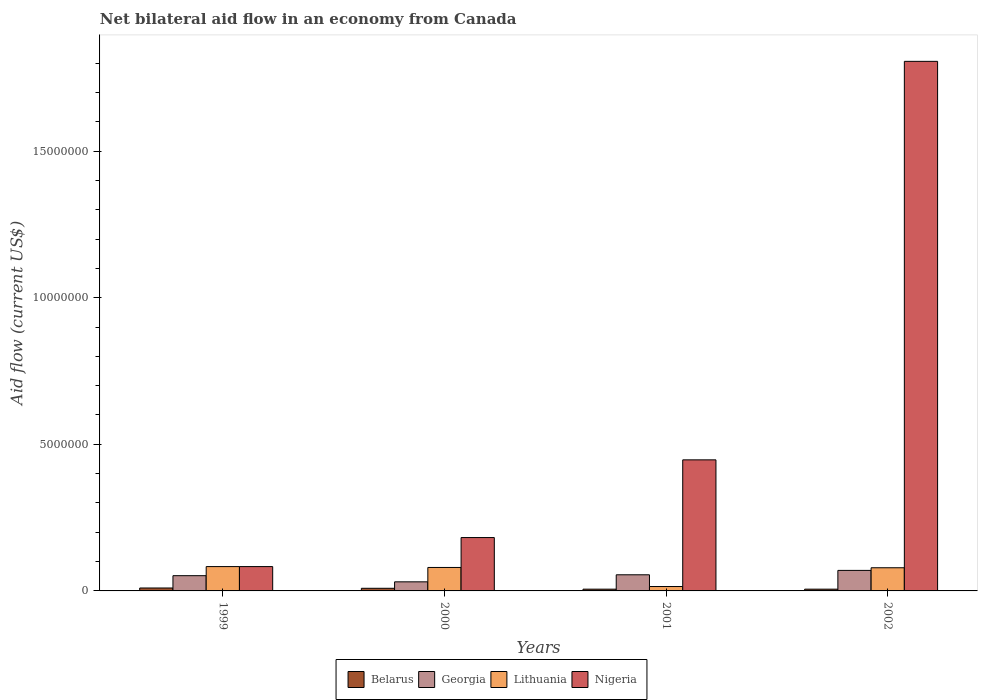Are the number of bars per tick equal to the number of legend labels?
Give a very brief answer. Yes. What is the label of the 3rd group of bars from the left?
Ensure brevity in your answer.  2001. In how many cases, is the number of bars for a given year not equal to the number of legend labels?
Keep it short and to the point. 0. What is the net bilateral aid flow in Georgia in 1999?
Offer a very short reply. 5.20e+05. Across all years, what is the maximum net bilateral aid flow in Lithuania?
Your response must be concise. 8.30e+05. In which year was the net bilateral aid flow in Lithuania maximum?
Offer a terse response. 1999. In which year was the net bilateral aid flow in Belarus minimum?
Your answer should be compact. 2001. What is the total net bilateral aid flow in Nigeria in the graph?
Ensure brevity in your answer.  2.52e+07. What is the difference between the net bilateral aid flow in Lithuania in 2001 and that in 2002?
Your answer should be very brief. -6.40e+05. What is the difference between the net bilateral aid flow in Belarus in 2001 and the net bilateral aid flow in Georgia in 1999?
Your answer should be very brief. -4.60e+05. What is the average net bilateral aid flow in Belarus per year?
Offer a terse response. 7.75e+04. In the year 2000, what is the difference between the net bilateral aid flow in Belarus and net bilateral aid flow in Lithuania?
Ensure brevity in your answer.  -7.10e+05. What is the ratio of the net bilateral aid flow in Belarus in 1999 to that in 2001?
Offer a very short reply. 1.67. What is the difference between the highest and the second highest net bilateral aid flow in Belarus?
Keep it short and to the point. 10000. What is the difference between the highest and the lowest net bilateral aid flow in Lithuania?
Ensure brevity in your answer.  6.80e+05. In how many years, is the net bilateral aid flow in Nigeria greater than the average net bilateral aid flow in Nigeria taken over all years?
Your answer should be very brief. 1. Is it the case that in every year, the sum of the net bilateral aid flow in Lithuania and net bilateral aid flow in Belarus is greater than the sum of net bilateral aid flow in Georgia and net bilateral aid flow in Nigeria?
Make the answer very short. No. What does the 3rd bar from the left in 2001 represents?
Offer a very short reply. Lithuania. What does the 4th bar from the right in 2000 represents?
Provide a short and direct response. Belarus. Is it the case that in every year, the sum of the net bilateral aid flow in Belarus and net bilateral aid flow in Georgia is greater than the net bilateral aid flow in Nigeria?
Your answer should be very brief. No. How many bars are there?
Give a very brief answer. 16. Are all the bars in the graph horizontal?
Ensure brevity in your answer.  No. Are the values on the major ticks of Y-axis written in scientific E-notation?
Provide a succinct answer. No. Does the graph contain grids?
Make the answer very short. No. Where does the legend appear in the graph?
Your response must be concise. Bottom center. How many legend labels are there?
Make the answer very short. 4. What is the title of the graph?
Keep it short and to the point. Net bilateral aid flow in an economy from Canada. What is the label or title of the X-axis?
Offer a very short reply. Years. What is the label or title of the Y-axis?
Your answer should be compact. Aid flow (current US$). What is the Aid flow (current US$) of Belarus in 1999?
Your answer should be compact. 1.00e+05. What is the Aid flow (current US$) in Georgia in 1999?
Your answer should be very brief. 5.20e+05. What is the Aid flow (current US$) of Lithuania in 1999?
Your response must be concise. 8.30e+05. What is the Aid flow (current US$) of Nigeria in 1999?
Provide a succinct answer. 8.30e+05. What is the Aid flow (current US$) in Belarus in 2000?
Keep it short and to the point. 9.00e+04. What is the Aid flow (current US$) in Lithuania in 2000?
Your response must be concise. 8.00e+05. What is the Aid flow (current US$) of Nigeria in 2000?
Provide a short and direct response. 1.82e+06. What is the Aid flow (current US$) of Georgia in 2001?
Ensure brevity in your answer.  5.50e+05. What is the Aid flow (current US$) of Lithuania in 2001?
Provide a succinct answer. 1.50e+05. What is the Aid flow (current US$) in Nigeria in 2001?
Your answer should be very brief. 4.47e+06. What is the Aid flow (current US$) of Lithuania in 2002?
Your response must be concise. 7.90e+05. What is the Aid flow (current US$) in Nigeria in 2002?
Keep it short and to the point. 1.81e+07. Across all years, what is the maximum Aid flow (current US$) in Georgia?
Offer a terse response. 7.00e+05. Across all years, what is the maximum Aid flow (current US$) in Lithuania?
Provide a succinct answer. 8.30e+05. Across all years, what is the maximum Aid flow (current US$) in Nigeria?
Offer a very short reply. 1.81e+07. Across all years, what is the minimum Aid flow (current US$) of Lithuania?
Ensure brevity in your answer.  1.50e+05. Across all years, what is the minimum Aid flow (current US$) in Nigeria?
Provide a short and direct response. 8.30e+05. What is the total Aid flow (current US$) in Georgia in the graph?
Your answer should be very brief. 2.08e+06. What is the total Aid flow (current US$) of Lithuania in the graph?
Your response must be concise. 2.57e+06. What is the total Aid flow (current US$) in Nigeria in the graph?
Ensure brevity in your answer.  2.52e+07. What is the difference between the Aid flow (current US$) of Georgia in 1999 and that in 2000?
Provide a succinct answer. 2.10e+05. What is the difference between the Aid flow (current US$) in Lithuania in 1999 and that in 2000?
Your answer should be compact. 3.00e+04. What is the difference between the Aid flow (current US$) in Nigeria in 1999 and that in 2000?
Offer a terse response. -9.90e+05. What is the difference between the Aid flow (current US$) of Belarus in 1999 and that in 2001?
Your answer should be compact. 4.00e+04. What is the difference between the Aid flow (current US$) in Georgia in 1999 and that in 2001?
Your response must be concise. -3.00e+04. What is the difference between the Aid flow (current US$) of Lithuania in 1999 and that in 2001?
Make the answer very short. 6.80e+05. What is the difference between the Aid flow (current US$) in Nigeria in 1999 and that in 2001?
Ensure brevity in your answer.  -3.64e+06. What is the difference between the Aid flow (current US$) in Georgia in 1999 and that in 2002?
Provide a short and direct response. -1.80e+05. What is the difference between the Aid flow (current US$) of Nigeria in 1999 and that in 2002?
Your answer should be very brief. -1.72e+07. What is the difference between the Aid flow (current US$) in Belarus in 2000 and that in 2001?
Make the answer very short. 3.00e+04. What is the difference between the Aid flow (current US$) of Lithuania in 2000 and that in 2001?
Your answer should be compact. 6.50e+05. What is the difference between the Aid flow (current US$) of Nigeria in 2000 and that in 2001?
Your response must be concise. -2.65e+06. What is the difference between the Aid flow (current US$) of Georgia in 2000 and that in 2002?
Your answer should be very brief. -3.90e+05. What is the difference between the Aid flow (current US$) in Lithuania in 2000 and that in 2002?
Offer a terse response. 10000. What is the difference between the Aid flow (current US$) of Nigeria in 2000 and that in 2002?
Offer a very short reply. -1.62e+07. What is the difference between the Aid flow (current US$) in Belarus in 2001 and that in 2002?
Ensure brevity in your answer.  0. What is the difference between the Aid flow (current US$) in Lithuania in 2001 and that in 2002?
Your answer should be very brief. -6.40e+05. What is the difference between the Aid flow (current US$) in Nigeria in 2001 and that in 2002?
Your answer should be compact. -1.36e+07. What is the difference between the Aid flow (current US$) in Belarus in 1999 and the Aid flow (current US$) in Lithuania in 2000?
Provide a short and direct response. -7.00e+05. What is the difference between the Aid flow (current US$) of Belarus in 1999 and the Aid flow (current US$) of Nigeria in 2000?
Provide a succinct answer. -1.72e+06. What is the difference between the Aid flow (current US$) in Georgia in 1999 and the Aid flow (current US$) in Lithuania in 2000?
Keep it short and to the point. -2.80e+05. What is the difference between the Aid flow (current US$) of Georgia in 1999 and the Aid flow (current US$) of Nigeria in 2000?
Offer a terse response. -1.30e+06. What is the difference between the Aid flow (current US$) of Lithuania in 1999 and the Aid flow (current US$) of Nigeria in 2000?
Provide a short and direct response. -9.90e+05. What is the difference between the Aid flow (current US$) in Belarus in 1999 and the Aid flow (current US$) in Georgia in 2001?
Your answer should be very brief. -4.50e+05. What is the difference between the Aid flow (current US$) of Belarus in 1999 and the Aid flow (current US$) of Nigeria in 2001?
Your answer should be very brief. -4.37e+06. What is the difference between the Aid flow (current US$) in Georgia in 1999 and the Aid flow (current US$) in Lithuania in 2001?
Offer a terse response. 3.70e+05. What is the difference between the Aid flow (current US$) of Georgia in 1999 and the Aid flow (current US$) of Nigeria in 2001?
Provide a short and direct response. -3.95e+06. What is the difference between the Aid flow (current US$) in Lithuania in 1999 and the Aid flow (current US$) in Nigeria in 2001?
Ensure brevity in your answer.  -3.64e+06. What is the difference between the Aid flow (current US$) of Belarus in 1999 and the Aid flow (current US$) of Georgia in 2002?
Your answer should be very brief. -6.00e+05. What is the difference between the Aid flow (current US$) of Belarus in 1999 and the Aid flow (current US$) of Lithuania in 2002?
Provide a short and direct response. -6.90e+05. What is the difference between the Aid flow (current US$) of Belarus in 1999 and the Aid flow (current US$) of Nigeria in 2002?
Your answer should be compact. -1.80e+07. What is the difference between the Aid flow (current US$) in Georgia in 1999 and the Aid flow (current US$) in Lithuania in 2002?
Make the answer very short. -2.70e+05. What is the difference between the Aid flow (current US$) in Georgia in 1999 and the Aid flow (current US$) in Nigeria in 2002?
Offer a very short reply. -1.75e+07. What is the difference between the Aid flow (current US$) in Lithuania in 1999 and the Aid flow (current US$) in Nigeria in 2002?
Make the answer very short. -1.72e+07. What is the difference between the Aid flow (current US$) in Belarus in 2000 and the Aid flow (current US$) in Georgia in 2001?
Make the answer very short. -4.60e+05. What is the difference between the Aid flow (current US$) of Belarus in 2000 and the Aid flow (current US$) of Lithuania in 2001?
Your response must be concise. -6.00e+04. What is the difference between the Aid flow (current US$) of Belarus in 2000 and the Aid flow (current US$) of Nigeria in 2001?
Provide a short and direct response. -4.38e+06. What is the difference between the Aid flow (current US$) in Georgia in 2000 and the Aid flow (current US$) in Nigeria in 2001?
Your answer should be very brief. -4.16e+06. What is the difference between the Aid flow (current US$) of Lithuania in 2000 and the Aid flow (current US$) of Nigeria in 2001?
Offer a very short reply. -3.67e+06. What is the difference between the Aid flow (current US$) of Belarus in 2000 and the Aid flow (current US$) of Georgia in 2002?
Give a very brief answer. -6.10e+05. What is the difference between the Aid flow (current US$) of Belarus in 2000 and the Aid flow (current US$) of Lithuania in 2002?
Your answer should be compact. -7.00e+05. What is the difference between the Aid flow (current US$) of Belarus in 2000 and the Aid flow (current US$) of Nigeria in 2002?
Offer a very short reply. -1.80e+07. What is the difference between the Aid flow (current US$) in Georgia in 2000 and the Aid flow (current US$) in Lithuania in 2002?
Keep it short and to the point. -4.80e+05. What is the difference between the Aid flow (current US$) of Georgia in 2000 and the Aid flow (current US$) of Nigeria in 2002?
Offer a terse response. -1.78e+07. What is the difference between the Aid flow (current US$) of Lithuania in 2000 and the Aid flow (current US$) of Nigeria in 2002?
Keep it short and to the point. -1.73e+07. What is the difference between the Aid flow (current US$) in Belarus in 2001 and the Aid flow (current US$) in Georgia in 2002?
Provide a short and direct response. -6.40e+05. What is the difference between the Aid flow (current US$) of Belarus in 2001 and the Aid flow (current US$) of Lithuania in 2002?
Your answer should be very brief. -7.30e+05. What is the difference between the Aid flow (current US$) in Belarus in 2001 and the Aid flow (current US$) in Nigeria in 2002?
Give a very brief answer. -1.80e+07. What is the difference between the Aid flow (current US$) of Georgia in 2001 and the Aid flow (current US$) of Lithuania in 2002?
Ensure brevity in your answer.  -2.40e+05. What is the difference between the Aid flow (current US$) of Georgia in 2001 and the Aid flow (current US$) of Nigeria in 2002?
Your answer should be very brief. -1.75e+07. What is the difference between the Aid flow (current US$) in Lithuania in 2001 and the Aid flow (current US$) in Nigeria in 2002?
Your answer should be very brief. -1.79e+07. What is the average Aid flow (current US$) of Belarus per year?
Ensure brevity in your answer.  7.75e+04. What is the average Aid flow (current US$) in Georgia per year?
Provide a succinct answer. 5.20e+05. What is the average Aid flow (current US$) of Lithuania per year?
Provide a short and direct response. 6.42e+05. What is the average Aid flow (current US$) of Nigeria per year?
Provide a succinct answer. 6.30e+06. In the year 1999, what is the difference between the Aid flow (current US$) of Belarus and Aid flow (current US$) of Georgia?
Ensure brevity in your answer.  -4.20e+05. In the year 1999, what is the difference between the Aid flow (current US$) of Belarus and Aid flow (current US$) of Lithuania?
Ensure brevity in your answer.  -7.30e+05. In the year 1999, what is the difference between the Aid flow (current US$) of Belarus and Aid flow (current US$) of Nigeria?
Your answer should be compact. -7.30e+05. In the year 1999, what is the difference between the Aid flow (current US$) of Georgia and Aid flow (current US$) of Lithuania?
Your answer should be very brief. -3.10e+05. In the year 1999, what is the difference between the Aid flow (current US$) in Georgia and Aid flow (current US$) in Nigeria?
Provide a short and direct response. -3.10e+05. In the year 1999, what is the difference between the Aid flow (current US$) of Lithuania and Aid flow (current US$) of Nigeria?
Ensure brevity in your answer.  0. In the year 2000, what is the difference between the Aid flow (current US$) in Belarus and Aid flow (current US$) in Georgia?
Your answer should be compact. -2.20e+05. In the year 2000, what is the difference between the Aid flow (current US$) of Belarus and Aid flow (current US$) of Lithuania?
Ensure brevity in your answer.  -7.10e+05. In the year 2000, what is the difference between the Aid flow (current US$) in Belarus and Aid flow (current US$) in Nigeria?
Provide a succinct answer. -1.73e+06. In the year 2000, what is the difference between the Aid flow (current US$) in Georgia and Aid flow (current US$) in Lithuania?
Your answer should be compact. -4.90e+05. In the year 2000, what is the difference between the Aid flow (current US$) in Georgia and Aid flow (current US$) in Nigeria?
Make the answer very short. -1.51e+06. In the year 2000, what is the difference between the Aid flow (current US$) of Lithuania and Aid flow (current US$) of Nigeria?
Your answer should be compact. -1.02e+06. In the year 2001, what is the difference between the Aid flow (current US$) in Belarus and Aid flow (current US$) in Georgia?
Provide a succinct answer. -4.90e+05. In the year 2001, what is the difference between the Aid flow (current US$) in Belarus and Aid flow (current US$) in Lithuania?
Provide a succinct answer. -9.00e+04. In the year 2001, what is the difference between the Aid flow (current US$) of Belarus and Aid flow (current US$) of Nigeria?
Offer a very short reply. -4.41e+06. In the year 2001, what is the difference between the Aid flow (current US$) in Georgia and Aid flow (current US$) in Lithuania?
Offer a terse response. 4.00e+05. In the year 2001, what is the difference between the Aid flow (current US$) of Georgia and Aid flow (current US$) of Nigeria?
Make the answer very short. -3.92e+06. In the year 2001, what is the difference between the Aid flow (current US$) in Lithuania and Aid flow (current US$) in Nigeria?
Provide a short and direct response. -4.32e+06. In the year 2002, what is the difference between the Aid flow (current US$) in Belarus and Aid flow (current US$) in Georgia?
Provide a succinct answer. -6.40e+05. In the year 2002, what is the difference between the Aid flow (current US$) in Belarus and Aid flow (current US$) in Lithuania?
Provide a short and direct response. -7.30e+05. In the year 2002, what is the difference between the Aid flow (current US$) in Belarus and Aid flow (current US$) in Nigeria?
Provide a succinct answer. -1.80e+07. In the year 2002, what is the difference between the Aid flow (current US$) in Georgia and Aid flow (current US$) in Lithuania?
Provide a short and direct response. -9.00e+04. In the year 2002, what is the difference between the Aid flow (current US$) of Georgia and Aid flow (current US$) of Nigeria?
Provide a short and direct response. -1.74e+07. In the year 2002, what is the difference between the Aid flow (current US$) in Lithuania and Aid flow (current US$) in Nigeria?
Your response must be concise. -1.73e+07. What is the ratio of the Aid flow (current US$) of Belarus in 1999 to that in 2000?
Offer a very short reply. 1.11. What is the ratio of the Aid flow (current US$) of Georgia in 1999 to that in 2000?
Ensure brevity in your answer.  1.68. What is the ratio of the Aid flow (current US$) in Lithuania in 1999 to that in 2000?
Provide a succinct answer. 1.04. What is the ratio of the Aid flow (current US$) in Nigeria in 1999 to that in 2000?
Keep it short and to the point. 0.46. What is the ratio of the Aid flow (current US$) of Georgia in 1999 to that in 2001?
Offer a very short reply. 0.95. What is the ratio of the Aid flow (current US$) in Lithuania in 1999 to that in 2001?
Your answer should be compact. 5.53. What is the ratio of the Aid flow (current US$) in Nigeria in 1999 to that in 2001?
Offer a terse response. 0.19. What is the ratio of the Aid flow (current US$) in Belarus in 1999 to that in 2002?
Your response must be concise. 1.67. What is the ratio of the Aid flow (current US$) of Georgia in 1999 to that in 2002?
Keep it short and to the point. 0.74. What is the ratio of the Aid flow (current US$) of Lithuania in 1999 to that in 2002?
Your answer should be compact. 1.05. What is the ratio of the Aid flow (current US$) in Nigeria in 1999 to that in 2002?
Keep it short and to the point. 0.05. What is the ratio of the Aid flow (current US$) in Belarus in 2000 to that in 2001?
Your response must be concise. 1.5. What is the ratio of the Aid flow (current US$) of Georgia in 2000 to that in 2001?
Provide a short and direct response. 0.56. What is the ratio of the Aid flow (current US$) in Lithuania in 2000 to that in 2001?
Ensure brevity in your answer.  5.33. What is the ratio of the Aid flow (current US$) of Nigeria in 2000 to that in 2001?
Keep it short and to the point. 0.41. What is the ratio of the Aid flow (current US$) of Belarus in 2000 to that in 2002?
Provide a succinct answer. 1.5. What is the ratio of the Aid flow (current US$) in Georgia in 2000 to that in 2002?
Your answer should be very brief. 0.44. What is the ratio of the Aid flow (current US$) of Lithuania in 2000 to that in 2002?
Ensure brevity in your answer.  1.01. What is the ratio of the Aid flow (current US$) of Nigeria in 2000 to that in 2002?
Offer a very short reply. 0.1. What is the ratio of the Aid flow (current US$) of Belarus in 2001 to that in 2002?
Provide a short and direct response. 1. What is the ratio of the Aid flow (current US$) in Georgia in 2001 to that in 2002?
Your response must be concise. 0.79. What is the ratio of the Aid flow (current US$) of Lithuania in 2001 to that in 2002?
Keep it short and to the point. 0.19. What is the ratio of the Aid flow (current US$) of Nigeria in 2001 to that in 2002?
Offer a very short reply. 0.25. What is the difference between the highest and the second highest Aid flow (current US$) in Lithuania?
Give a very brief answer. 3.00e+04. What is the difference between the highest and the second highest Aid flow (current US$) in Nigeria?
Your answer should be compact. 1.36e+07. What is the difference between the highest and the lowest Aid flow (current US$) in Belarus?
Your response must be concise. 4.00e+04. What is the difference between the highest and the lowest Aid flow (current US$) in Georgia?
Offer a very short reply. 3.90e+05. What is the difference between the highest and the lowest Aid flow (current US$) in Lithuania?
Your response must be concise. 6.80e+05. What is the difference between the highest and the lowest Aid flow (current US$) in Nigeria?
Your response must be concise. 1.72e+07. 